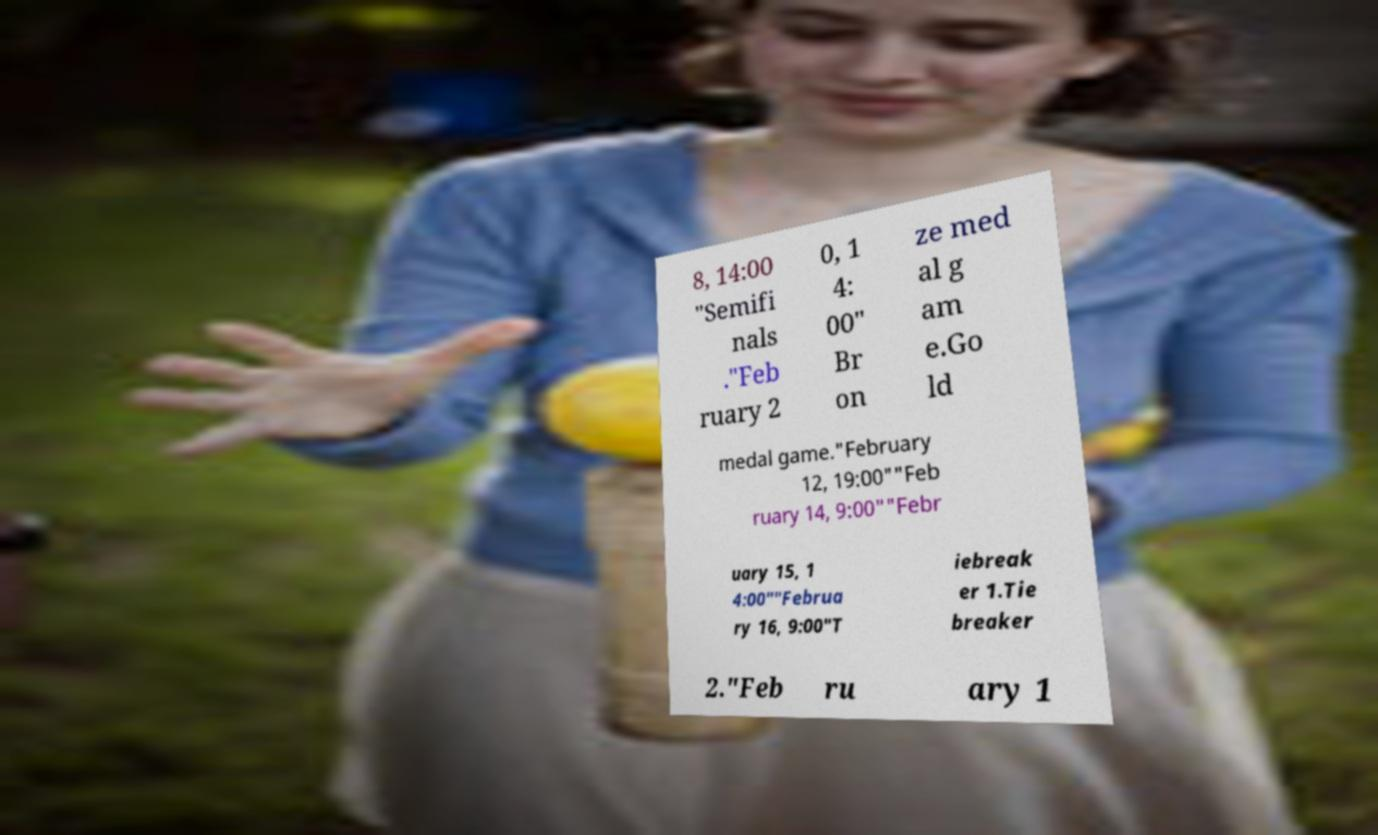I need the written content from this picture converted into text. Can you do that? 8, 14:00 "Semifi nals ."Feb ruary 2 0, 1 4: 00" Br on ze med al g am e.Go ld medal game."February 12, 19:00""Feb ruary 14, 9:00""Febr uary 15, 1 4:00""Februa ry 16, 9:00"T iebreak er 1.Tie breaker 2."Feb ru ary 1 